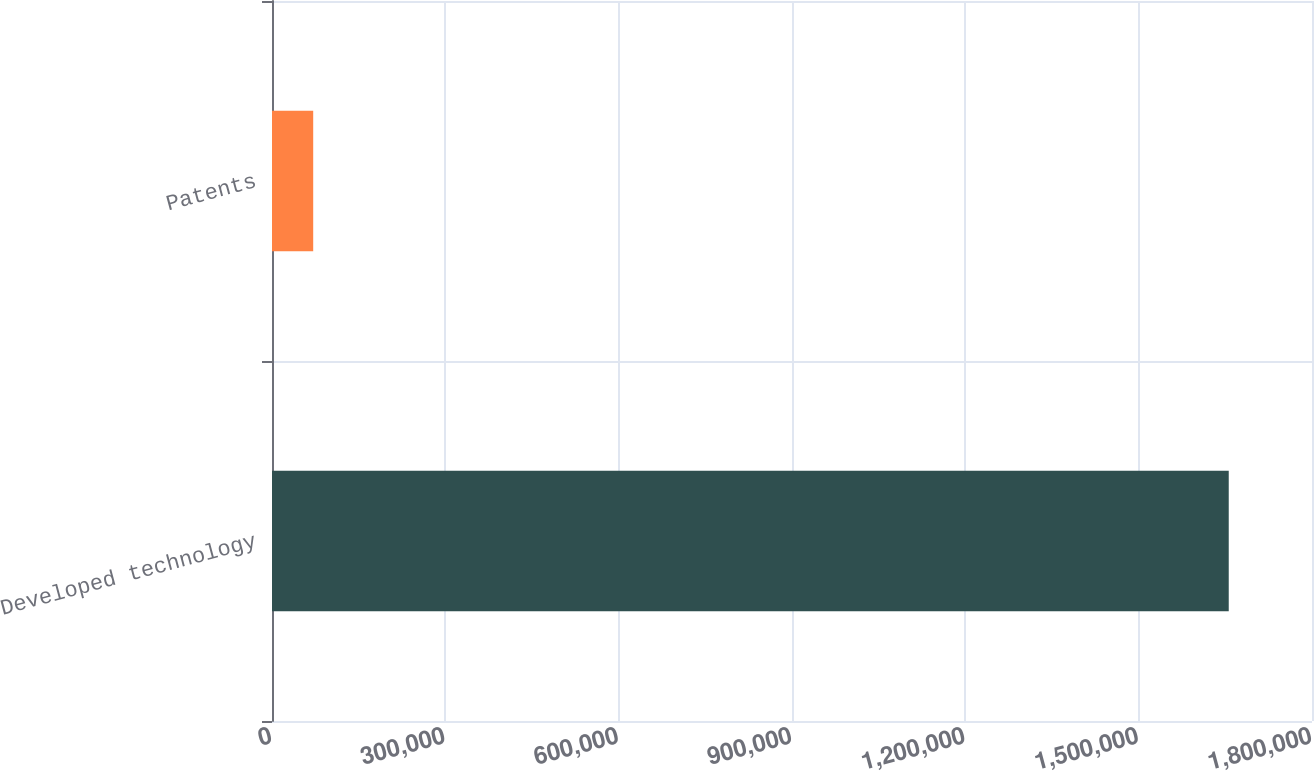<chart> <loc_0><loc_0><loc_500><loc_500><bar_chart><fcel>Developed technology<fcel>Patents<nl><fcel>1.6559e+06<fcel>71313<nl></chart> 